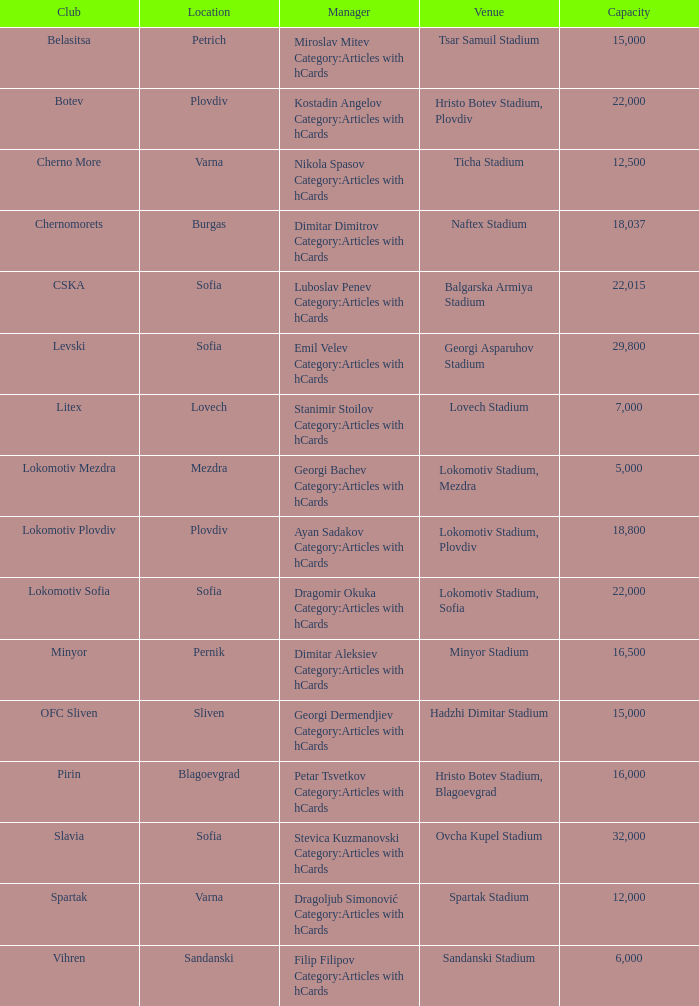What is the highest capacity for the venue of the club, vihren? 6000.0. Would you be able to parse every entry in this table? {'header': ['Club', 'Location', 'Manager', 'Venue', 'Capacity'], 'rows': [['Belasitsa', 'Petrich', 'Miroslav Mitev Category:Articles with hCards', 'Tsar Samuil Stadium', '15,000'], ['Botev', 'Plovdiv', 'Kostadin Angelov Category:Articles with hCards', 'Hristo Botev Stadium, Plovdiv', '22,000'], ['Cherno More', 'Varna', 'Nikola Spasov Category:Articles with hCards', 'Ticha Stadium', '12,500'], ['Chernomorets', 'Burgas', 'Dimitar Dimitrov Category:Articles with hCards', 'Naftex Stadium', '18,037'], ['CSKA', 'Sofia', 'Luboslav Penev Category:Articles with hCards', 'Balgarska Armiya Stadium', '22,015'], ['Levski', 'Sofia', 'Emil Velev Category:Articles with hCards', 'Georgi Asparuhov Stadium', '29,800'], ['Litex', 'Lovech', 'Stanimir Stoilov Category:Articles with hCards', 'Lovech Stadium', '7,000'], ['Lokomotiv Mezdra', 'Mezdra', 'Georgi Bachev Category:Articles with hCards', 'Lokomotiv Stadium, Mezdra', '5,000'], ['Lokomotiv Plovdiv', 'Plovdiv', 'Ayan Sadakov Category:Articles with hCards', 'Lokomotiv Stadium, Plovdiv', '18,800'], ['Lokomotiv Sofia', 'Sofia', 'Dragomir Okuka Category:Articles with hCards', 'Lokomotiv Stadium, Sofia', '22,000'], ['Minyor', 'Pernik', 'Dimitar Aleksiev Category:Articles with hCards', 'Minyor Stadium', '16,500'], ['OFC Sliven', 'Sliven', 'Georgi Dermendjiev Category:Articles with hCards', 'Hadzhi Dimitar Stadium', '15,000'], ['Pirin', 'Blagoevgrad', 'Petar Tsvetkov Category:Articles with hCards', 'Hristo Botev Stadium, Blagoevgrad', '16,000'], ['Slavia', 'Sofia', 'Stevica Kuzmanovski Category:Articles with hCards', 'Ovcha Kupel Stadium', '32,000'], ['Spartak', 'Varna', 'Dragoljub Simonović Category:Articles with hCards', 'Spartak Stadium', '12,000'], ['Vihren', 'Sandanski', 'Filip Filipov Category:Articles with hCards', 'Sandanski Stadium', '6,000']]} 